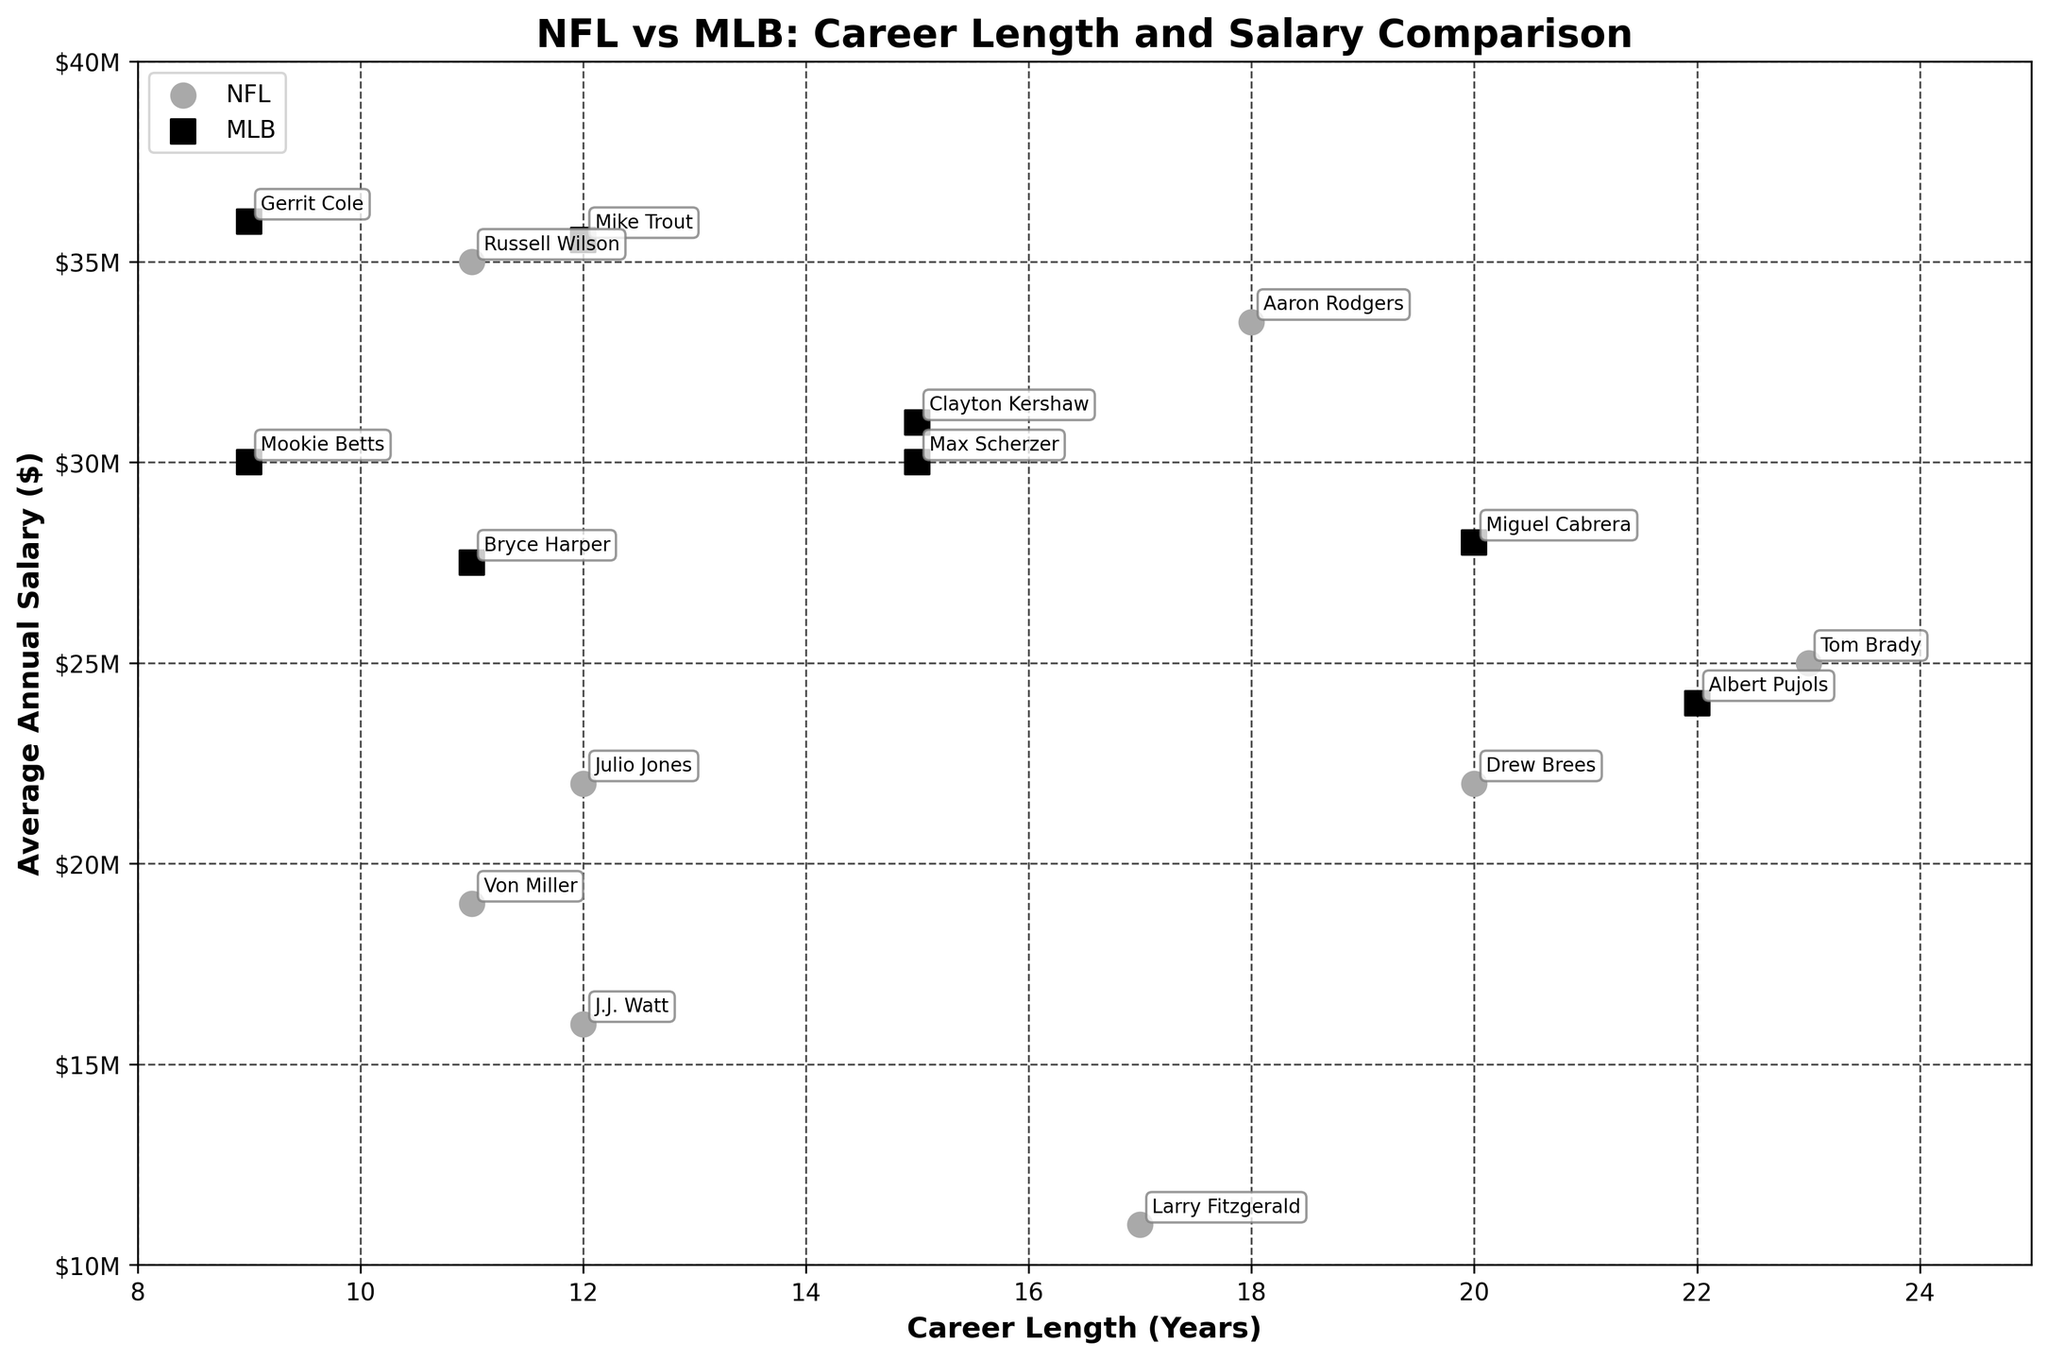What is the title of the plot? The title of the plot is usually displayed prominently at the top of the figure. It provides a concise description of what the plot is illustrating. In this case, it is comparing career length and salary between NFL and MLB players.
Answer: "NFL vs MLB: Career Length and Salary Comparison" How many NFL players are shown in the plot? The NFL players can be identified by the color and marker type. Specifically, they are represented by dark gray circles. Count the number of such markers in the plot.
Answer: 8 What is the career length of the player with the highest average annual salary? Identify the data point with the highest y-value (average annual salary) and then read the corresponding x-value (career length). Gerrit Cole, an MLB player, has the highest average annual salary, which is $36 million.
Answer: 9 years Which league has a higher overall average annual salary among the players shown? Calculate the average annual salary for both NFL and MLB players separately by adding their respective salaries and dividing by the number of players in each league. Compare the two averages. NFL: (25000000 + 22000000 + 33500000 + 16000000 + 11000000 + 22000000 + 35000000 + 19000000) / 8 = 23.75 million. MLB: (24000000 + 31000000 + 35540000 + 30000000 + 28000000 + 27500000 + 36000000 + 30000000) / 8 = 30.8 million.
Answer: MLB Among the NFL players, who has the shortest career length, and what is their salary? Identify the NFL player with the lowest x-value (career length) and then read their y-value (average annual salary).
Answer: Russell Wilson, $35 million Compare the career lengths of Tom Brady and Albert Pujols. Who had a longer career, and by how many years? Tom Brady and Albert Pujols are spotted on the plot. From the figure, read off their career lengths from the x-axis and subtract to find the difference. Tom Brady has 23 years, and Albert Pujols has 22 years.
Answer: Tom Brady by 1 year What is the average career length of MLB players depicted in the plot? Calculate the average career length by adding the career lengths of MLB players and dividing by the number of MLB players. (22 + 15 + 12 + 15 + 20 + 11 + 9 + 9) / 8 = 14.125 years.
Answer: 14.125 years Who is positioned closest to the average career length and salary for NFL players? Calculate the mean career length and annual salary for NFL players, then find the data point closest to this mean by visually or numerically estimating the proximity in the plot. NFL average career length is 14.5 years, and the average annual salary is 23.75 million. Larry Fitzgerald is closest to this point.
Answer: Larry Fitzgerald 